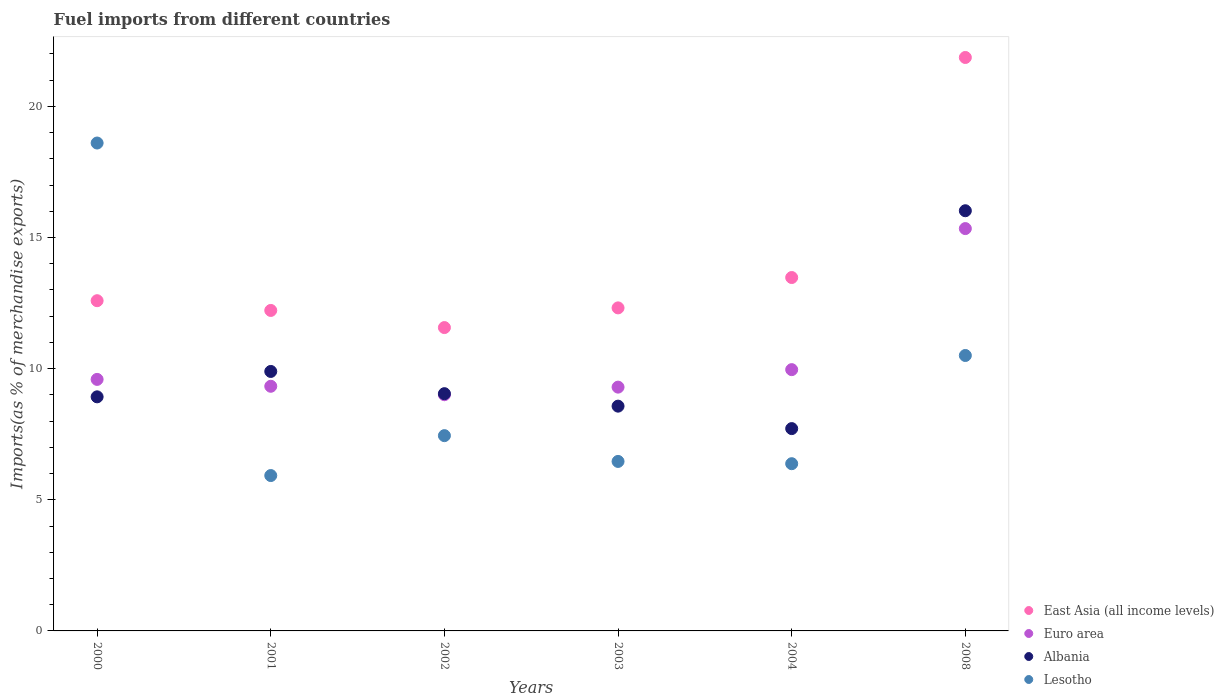Is the number of dotlines equal to the number of legend labels?
Give a very brief answer. Yes. What is the percentage of imports to different countries in Lesotho in 2000?
Provide a succinct answer. 18.6. Across all years, what is the maximum percentage of imports to different countries in Albania?
Ensure brevity in your answer.  16.02. Across all years, what is the minimum percentage of imports to different countries in Lesotho?
Make the answer very short. 5.92. In which year was the percentage of imports to different countries in Lesotho maximum?
Offer a very short reply. 2000. What is the total percentage of imports to different countries in East Asia (all income levels) in the graph?
Offer a very short reply. 84.03. What is the difference between the percentage of imports to different countries in Lesotho in 2001 and that in 2003?
Make the answer very short. -0.54. What is the difference between the percentage of imports to different countries in Euro area in 2003 and the percentage of imports to different countries in Lesotho in 2000?
Keep it short and to the point. -9.31. What is the average percentage of imports to different countries in Albania per year?
Your answer should be compact. 10.03. In the year 2003, what is the difference between the percentage of imports to different countries in Euro area and percentage of imports to different countries in Lesotho?
Your response must be concise. 2.83. In how many years, is the percentage of imports to different countries in Lesotho greater than 11 %?
Keep it short and to the point. 1. What is the ratio of the percentage of imports to different countries in Euro area in 2001 to that in 2004?
Your answer should be compact. 0.94. Is the percentage of imports to different countries in Lesotho in 2000 less than that in 2003?
Your answer should be compact. No. What is the difference between the highest and the second highest percentage of imports to different countries in Albania?
Your answer should be compact. 6.13. What is the difference between the highest and the lowest percentage of imports to different countries in Albania?
Provide a short and direct response. 8.31. Is the sum of the percentage of imports to different countries in Lesotho in 2000 and 2003 greater than the maximum percentage of imports to different countries in East Asia (all income levels) across all years?
Offer a very short reply. Yes. Is it the case that in every year, the sum of the percentage of imports to different countries in Euro area and percentage of imports to different countries in Lesotho  is greater than the percentage of imports to different countries in Albania?
Your answer should be very brief. Yes. Is the percentage of imports to different countries in Albania strictly less than the percentage of imports to different countries in Lesotho over the years?
Give a very brief answer. No. How many years are there in the graph?
Your response must be concise. 6. What is the difference between two consecutive major ticks on the Y-axis?
Your answer should be compact. 5. Where does the legend appear in the graph?
Make the answer very short. Bottom right. How are the legend labels stacked?
Your answer should be compact. Vertical. What is the title of the graph?
Your answer should be compact. Fuel imports from different countries. What is the label or title of the X-axis?
Give a very brief answer. Years. What is the label or title of the Y-axis?
Your answer should be compact. Imports(as % of merchandise exports). What is the Imports(as % of merchandise exports) in East Asia (all income levels) in 2000?
Your answer should be compact. 12.59. What is the Imports(as % of merchandise exports) of Euro area in 2000?
Make the answer very short. 9.59. What is the Imports(as % of merchandise exports) of Albania in 2000?
Keep it short and to the point. 8.93. What is the Imports(as % of merchandise exports) in Lesotho in 2000?
Ensure brevity in your answer.  18.6. What is the Imports(as % of merchandise exports) in East Asia (all income levels) in 2001?
Make the answer very short. 12.22. What is the Imports(as % of merchandise exports) of Euro area in 2001?
Give a very brief answer. 9.33. What is the Imports(as % of merchandise exports) of Albania in 2001?
Your response must be concise. 9.89. What is the Imports(as % of merchandise exports) of Lesotho in 2001?
Offer a very short reply. 5.92. What is the Imports(as % of merchandise exports) in East Asia (all income levels) in 2002?
Keep it short and to the point. 11.57. What is the Imports(as % of merchandise exports) of Euro area in 2002?
Offer a very short reply. 9.01. What is the Imports(as % of merchandise exports) in Albania in 2002?
Ensure brevity in your answer.  9.05. What is the Imports(as % of merchandise exports) of Lesotho in 2002?
Your answer should be very brief. 7.45. What is the Imports(as % of merchandise exports) of East Asia (all income levels) in 2003?
Your answer should be very brief. 12.32. What is the Imports(as % of merchandise exports) of Euro area in 2003?
Give a very brief answer. 9.3. What is the Imports(as % of merchandise exports) of Albania in 2003?
Give a very brief answer. 8.57. What is the Imports(as % of merchandise exports) in Lesotho in 2003?
Provide a short and direct response. 6.46. What is the Imports(as % of merchandise exports) in East Asia (all income levels) in 2004?
Provide a succinct answer. 13.47. What is the Imports(as % of merchandise exports) in Euro area in 2004?
Keep it short and to the point. 9.96. What is the Imports(as % of merchandise exports) of Albania in 2004?
Your response must be concise. 7.71. What is the Imports(as % of merchandise exports) of Lesotho in 2004?
Make the answer very short. 6.38. What is the Imports(as % of merchandise exports) in East Asia (all income levels) in 2008?
Offer a terse response. 21.87. What is the Imports(as % of merchandise exports) of Euro area in 2008?
Your response must be concise. 15.34. What is the Imports(as % of merchandise exports) in Albania in 2008?
Offer a terse response. 16.02. What is the Imports(as % of merchandise exports) of Lesotho in 2008?
Your response must be concise. 10.5. Across all years, what is the maximum Imports(as % of merchandise exports) in East Asia (all income levels)?
Offer a terse response. 21.87. Across all years, what is the maximum Imports(as % of merchandise exports) in Euro area?
Your answer should be very brief. 15.34. Across all years, what is the maximum Imports(as % of merchandise exports) in Albania?
Provide a succinct answer. 16.02. Across all years, what is the maximum Imports(as % of merchandise exports) in Lesotho?
Provide a short and direct response. 18.6. Across all years, what is the minimum Imports(as % of merchandise exports) in East Asia (all income levels)?
Provide a succinct answer. 11.57. Across all years, what is the minimum Imports(as % of merchandise exports) of Euro area?
Offer a terse response. 9.01. Across all years, what is the minimum Imports(as % of merchandise exports) of Albania?
Your answer should be compact. 7.71. Across all years, what is the minimum Imports(as % of merchandise exports) of Lesotho?
Ensure brevity in your answer.  5.92. What is the total Imports(as % of merchandise exports) in East Asia (all income levels) in the graph?
Your response must be concise. 84.03. What is the total Imports(as % of merchandise exports) of Euro area in the graph?
Your answer should be very brief. 62.52. What is the total Imports(as % of merchandise exports) in Albania in the graph?
Provide a succinct answer. 60.17. What is the total Imports(as % of merchandise exports) of Lesotho in the graph?
Provide a succinct answer. 55.31. What is the difference between the Imports(as % of merchandise exports) of East Asia (all income levels) in 2000 and that in 2001?
Offer a terse response. 0.37. What is the difference between the Imports(as % of merchandise exports) in Euro area in 2000 and that in 2001?
Provide a succinct answer. 0.26. What is the difference between the Imports(as % of merchandise exports) in Albania in 2000 and that in 2001?
Your answer should be very brief. -0.97. What is the difference between the Imports(as % of merchandise exports) of Lesotho in 2000 and that in 2001?
Your answer should be compact. 12.68. What is the difference between the Imports(as % of merchandise exports) of East Asia (all income levels) in 2000 and that in 2002?
Offer a very short reply. 1.02. What is the difference between the Imports(as % of merchandise exports) in Euro area in 2000 and that in 2002?
Provide a short and direct response. 0.58. What is the difference between the Imports(as % of merchandise exports) of Albania in 2000 and that in 2002?
Keep it short and to the point. -0.12. What is the difference between the Imports(as % of merchandise exports) of Lesotho in 2000 and that in 2002?
Your answer should be compact. 11.16. What is the difference between the Imports(as % of merchandise exports) of East Asia (all income levels) in 2000 and that in 2003?
Your answer should be compact. 0.27. What is the difference between the Imports(as % of merchandise exports) in Euro area in 2000 and that in 2003?
Offer a terse response. 0.29. What is the difference between the Imports(as % of merchandise exports) in Albania in 2000 and that in 2003?
Provide a short and direct response. 0.36. What is the difference between the Imports(as % of merchandise exports) of Lesotho in 2000 and that in 2003?
Ensure brevity in your answer.  12.14. What is the difference between the Imports(as % of merchandise exports) in East Asia (all income levels) in 2000 and that in 2004?
Provide a short and direct response. -0.88. What is the difference between the Imports(as % of merchandise exports) in Euro area in 2000 and that in 2004?
Give a very brief answer. -0.37. What is the difference between the Imports(as % of merchandise exports) in Albania in 2000 and that in 2004?
Your answer should be very brief. 1.21. What is the difference between the Imports(as % of merchandise exports) in Lesotho in 2000 and that in 2004?
Make the answer very short. 12.23. What is the difference between the Imports(as % of merchandise exports) of East Asia (all income levels) in 2000 and that in 2008?
Offer a terse response. -9.27. What is the difference between the Imports(as % of merchandise exports) of Euro area in 2000 and that in 2008?
Offer a very short reply. -5.75. What is the difference between the Imports(as % of merchandise exports) in Albania in 2000 and that in 2008?
Your answer should be very brief. -7.1. What is the difference between the Imports(as % of merchandise exports) of Lesotho in 2000 and that in 2008?
Give a very brief answer. 8.1. What is the difference between the Imports(as % of merchandise exports) in East Asia (all income levels) in 2001 and that in 2002?
Provide a short and direct response. 0.65. What is the difference between the Imports(as % of merchandise exports) in Euro area in 2001 and that in 2002?
Provide a succinct answer. 0.32. What is the difference between the Imports(as % of merchandise exports) in Albania in 2001 and that in 2002?
Ensure brevity in your answer.  0.85. What is the difference between the Imports(as % of merchandise exports) in Lesotho in 2001 and that in 2002?
Your answer should be very brief. -1.52. What is the difference between the Imports(as % of merchandise exports) in East Asia (all income levels) in 2001 and that in 2003?
Offer a very short reply. -0.1. What is the difference between the Imports(as % of merchandise exports) of Euro area in 2001 and that in 2003?
Your response must be concise. 0.03. What is the difference between the Imports(as % of merchandise exports) in Albania in 2001 and that in 2003?
Your response must be concise. 1.32. What is the difference between the Imports(as % of merchandise exports) of Lesotho in 2001 and that in 2003?
Provide a succinct answer. -0.54. What is the difference between the Imports(as % of merchandise exports) of East Asia (all income levels) in 2001 and that in 2004?
Offer a terse response. -1.25. What is the difference between the Imports(as % of merchandise exports) in Euro area in 2001 and that in 2004?
Your answer should be very brief. -0.63. What is the difference between the Imports(as % of merchandise exports) of Albania in 2001 and that in 2004?
Provide a short and direct response. 2.18. What is the difference between the Imports(as % of merchandise exports) of Lesotho in 2001 and that in 2004?
Your answer should be very brief. -0.45. What is the difference between the Imports(as % of merchandise exports) of East Asia (all income levels) in 2001 and that in 2008?
Provide a succinct answer. -9.65. What is the difference between the Imports(as % of merchandise exports) in Euro area in 2001 and that in 2008?
Offer a very short reply. -6.01. What is the difference between the Imports(as % of merchandise exports) in Albania in 2001 and that in 2008?
Your answer should be compact. -6.13. What is the difference between the Imports(as % of merchandise exports) of Lesotho in 2001 and that in 2008?
Offer a terse response. -4.58. What is the difference between the Imports(as % of merchandise exports) in East Asia (all income levels) in 2002 and that in 2003?
Give a very brief answer. -0.75. What is the difference between the Imports(as % of merchandise exports) of Euro area in 2002 and that in 2003?
Provide a succinct answer. -0.29. What is the difference between the Imports(as % of merchandise exports) of Albania in 2002 and that in 2003?
Offer a very short reply. 0.48. What is the difference between the Imports(as % of merchandise exports) in Lesotho in 2002 and that in 2003?
Give a very brief answer. 0.98. What is the difference between the Imports(as % of merchandise exports) of East Asia (all income levels) in 2002 and that in 2004?
Ensure brevity in your answer.  -1.91. What is the difference between the Imports(as % of merchandise exports) of Euro area in 2002 and that in 2004?
Ensure brevity in your answer.  -0.96. What is the difference between the Imports(as % of merchandise exports) of Albania in 2002 and that in 2004?
Ensure brevity in your answer.  1.33. What is the difference between the Imports(as % of merchandise exports) of Lesotho in 2002 and that in 2004?
Keep it short and to the point. 1.07. What is the difference between the Imports(as % of merchandise exports) in East Asia (all income levels) in 2002 and that in 2008?
Keep it short and to the point. -10.3. What is the difference between the Imports(as % of merchandise exports) in Euro area in 2002 and that in 2008?
Provide a succinct answer. -6.33. What is the difference between the Imports(as % of merchandise exports) of Albania in 2002 and that in 2008?
Your answer should be very brief. -6.97. What is the difference between the Imports(as % of merchandise exports) in Lesotho in 2002 and that in 2008?
Give a very brief answer. -3.06. What is the difference between the Imports(as % of merchandise exports) in East Asia (all income levels) in 2003 and that in 2004?
Keep it short and to the point. -1.16. What is the difference between the Imports(as % of merchandise exports) in Euro area in 2003 and that in 2004?
Your response must be concise. -0.67. What is the difference between the Imports(as % of merchandise exports) of Albania in 2003 and that in 2004?
Offer a very short reply. 0.86. What is the difference between the Imports(as % of merchandise exports) of Lesotho in 2003 and that in 2004?
Ensure brevity in your answer.  0.09. What is the difference between the Imports(as % of merchandise exports) in East Asia (all income levels) in 2003 and that in 2008?
Provide a short and direct response. -9.55. What is the difference between the Imports(as % of merchandise exports) of Euro area in 2003 and that in 2008?
Provide a short and direct response. -6.05. What is the difference between the Imports(as % of merchandise exports) in Albania in 2003 and that in 2008?
Make the answer very short. -7.45. What is the difference between the Imports(as % of merchandise exports) in Lesotho in 2003 and that in 2008?
Offer a very short reply. -4.04. What is the difference between the Imports(as % of merchandise exports) in East Asia (all income levels) in 2004 and that in 2008?
Keep it short and to the point. -8.39. What is the difference between the Imports(as % of merchandise exports) of Euro area in 2004 and that in 2008?
Your response must be concise. -5.38. What is the difference between the Imports(as % of merchandise exports) of Albania in 2004 and that in 2008?
Provide a short and direct response. -8.31. What is the difference between the Imports(as % of merchandise exports) of Lesotho in 2004 and that in 2008?
Offer a very short reply. -4.13. What is the difference between the Imports(as % of merchandise exports) in East Asia (all income levels) in 2000 and the Imports(as % of merchandise exports) in Euro area in 2001?
Your response must be concise. 3.26. What is the difference between the Imports(as % of merchandise exports) in East Asia (all income levels) in 2000 and the Imports(as % of merchandise exports) in Albania in 2001?
Your answer should be compact. 2.7. What is the difference between the Imports(as % of merchandise exports) of East Asia (all income levels) in 2000 and the Imports(as % of merchandise exports) of Lesotho in 2001?
Offer a very short reply. 6.67. What is the difference between the Imports(as % of merchandise exports) of Euro area in 2000 and the Imports(as % of merchandise exports) of Albania in 2001?
Your answer should be very brief. -0.3. What is the difference between the Imports(as % of merchandise exports) in Euro area in 2000 and the Imports(as % of merchandise exports) in Lesotho in 2001?
Offer a very short reply. 3.67. What is the difference between the Imports(as % of merchandise exports) of Albania in 2000 and the Imports(as % of merchandise exports) of Lesotho in 2001?
Your answer should be very brief. 3. What is the difference between the Imports(as % of merchandise exports) of East Asia (all income levels) in 2000 and the Imports(as % of merchandise exports) of Euro area in 2002?
Offer a terse response. 3.59. What is the difference between the Imports(as % of merchandise exports) in East Asia (all income levels) in 2000 and the Imports(as % of merchandise exports) in Albania in 2002?
Your answer should be very brief. 3.54. What is the difference between the Imports(as % of merchandise exports) of East Asia (all income levels) in 2000 and the Imports(as % of merchandise exports) of Lesotho in 2002?
Offer a very short reply. 5.15. What is the difference between the Imports(as % of merchandise exports) of Euro area in 2000 and the Imports(as % of merchandise exports) of Albania in 2002?
Offer a very short reply. 0.54. What is the difference between the Imports(as % of merchandise exports) of Euro area in 2000 and the Imports(as % of merchandise exports) of Lesotho in 2002?
Offer a very short reply. 2.14. What is the difference between the Imports(as % of merchandise exports) in Albania in 2000 and the Imports(as % of merchandise exports) in Lesotho in 2002?
Give a very brief answer. 1.48. What is the difference between the Imports(as % of merchandise exports) in East Asia (all income levels) in 2000 and the Imports(as % of merchandise exports) in Euro area in 2003?
Your answer should be very brief. 3.3. What is the difference between the Imports(as % of merchandise exports) of East Asia (all income levels) in 2000 and the Imports(as % of merchandise exports) of Albania in 2003?
Offer a terse response. 4.02. What is the difference between the Imports(as % of merchandise exports) of East Asia (all income levels) in 2000 and the Imports(as % of merchandise exports) of Lesotho in 2003?
Keep it short and to the point. 6.13. What is the difference between the Imports(as % of merchandise exports) in Euro area in 2000 and the Imports(as % of merchandise exports) in Albania in 2003?
Provide a succinct answer. 1.02. What is the difference between the Imports(as % of merchandise exports) of Euro area in 2000 and the Imports(as % of merchandise exports) of Lesotho in 2003?
Offer a very short reply. 3.13. What is the difference between the Imports(as % of merchandise exports) in Albania in 2000 and the Imports(as % of merchandise exports) in Lesotho in 2003?
Your answer should be very brief. 2.46. What is the difference between the Imports(as % of merchandise exports) in East Asia (all income levels) in 2000 and the Imports(as % of merchandise exports) in Euro area in 2004?
Offer a very short reply. 2.63. What is the difference between the Imports(as % of merchandise exports) in East Asia (all income levels) in 2000 and the Imports(as % of merchandise exports) in Albania in 2004?
Your answer should be very brief. 4.88. What is the difference between the Imports(as % of merchandise exports) in East Asia (all income levels) in 2000 and the Imports(as % of merchandise exports) in Lesotho in 2004?
Offer a very short reply. 6.21. What is the difference between the Imports(as % of merchandise exports) of Euro area in 2000 and the Imports(as % of merchandise exports) of Albania in 2004?
Offer a terse response. 1.88. What is the difference between the Imports(as % of merchandise exports) of Euro area in 2000 and the Imports(as % of merchandise exports) of Lesotho in 2004?
Offer a terse response. 3.21. What is the difference between the Imports(as % of merchandise exports) of Albania in 2000 and the Imports(as % of merchandise exports) of Lesotho in 2004?
Ensure brevity in your answer.  2.55. What is the difference between the Imports(as % of merchandise exports) of East Asia (all income levels) in 2000 and the Imports(as % of merchandise exports) of Euro area in 2008?
Offer a terse response. -2.75. What is the difference between the Imports(as % of merchandise exports) of East Asia (all income levels) in 2000 and the Imports(as % of merchandise exports) of Albania in 2008?
Give a very brief answer. -3.43. What is the difference between the Imports(as % of merchandise exports) in East Asia (all income levels) in 2000 and the Imports(as % of merchandise exports) in Lesotho in 2008?
Ensure brevity in your answer.  2.09. What is the difference between the Imports(as % of merchandise exports) in Euro area in 2000 and the Imports(as % of merchandise exports) in Albania in 2008?
Ensure brevity in your answer.  -6.43. What is the difference between the Imports(as % of merchandise exports) in Euro area in 2000 and the Imports(as % of merchandise exports) in Lesotho in 2008?
Give a very brief answer. -0.91. What is the difference between the Imports(as % of merchandise exports) in Albania in 2000 and the Imports(as % of merchandise exports) in Lesotho in 2008?
Offer a very short reply. -1.58. What is the difference between the Imports(as % of merchandise exports) of East Asia (all income levels) in 2001 and the Imports(as % of merchandise exports) of Euro area in 2002?
Provide a short and direct response. 3.21. What is the difference between the Imports(as % of merchandise exports) in East Asia (all income levels) in 2001 and the Imports(as % of merchandise exports) in Albania in 2002?
Provide a short and direct response. 3.17. What is the difference between the Imports(as % of merchandise exports) in East Asia (all income levels) in 2001 and the Imports(as % of merchandise exports) in Lesotho in 2002?
Give a very brief answer. 4.77. What is the difference between the Imports(as % of merchandise exports) of Euro area in 2001 and the Imports(as % of merchandise exports) of Albania in 2002?
Your answer should be compact. 0.28. What is the difference between the Imports(as % of merchandise exports) of Euro area in 2001 and the Imports(as % of merchandise exports) of Lesotho in 2002?
Your answer should be compact. 1.88. What is the difference between the Imports(as % of merchandise exports) of Albania in 2001 and the Imports(as % of merchandise exports) of Lesotho in 2002?
Make the answer very short. 2.45. What is the difference between the Imports(as % of merchandise exports) in East Asia (all income levels) in 2001 and the Imports(as % of merchandise exports) in Euro area in 2003?
Your response must be concise. 2.92. What is the difference between the Imports(as % of merchandise exports) of East Asia (all income levels) in 2001 and the Imports(as % of merchandise exports) of Albania in 2003?
Your answer should be compact. 3.65. What is the difference between the Imports(as % of merchandise exports) in East Asia (all income levels) in 2001 and the Imports(as % of merchandise exports) in Lesotho in 2003?
Make the answer very short. 5.76. What is the difference between the Imports(as % of merchandise exports) in Euro area in 2001 and the Imports(as % of merchandise exports) in Albania in 2003?
Make the answer very short. 0.76. What is the difference between the Imports(as % of merchandise exports) in Euro area in 2001 and the Imports(as % of merchandise exports) in Lesotho in 2003?
Provide a short and direct response. 2.87. What is the difference between the Imports(as % of merchandise exports) in Albania in 2001 and the Imports(as % of merchandise exports) in Lesotho in 2003?
Offer a very short reply. 3.43. What is the difference between the Imports(as % of merchandise exports) in East Asia (all income levels) in 2001 and the Imports(as % of merchandise exports) in Euro area in 2004?
Provide a succinct answer. 2.26. What is the difference between the Imports(as % of merchandise exports) in East Asia (all income levels) in 2001 and the Imports(as % of merchandise exports) in Albania in 2004?
Ensure brevity in your answer.  4.51. What is the difference between the Imports(as % of merchandise exports) of East Asia (all income levels) in 2001 and the Imports(as % of merchandise exports) of Lesotho in 2004?
Your response must be concise. 5.84. What is the difference between the Imports(as % of merchandise exports) of Euro area in 2001 and the Imports(as % of merchandise exports) of Albania in 2004?
Your answer should be compact. 1.61. What is the difference between the Imports(as % of merchandise exports) in Euro area in 2001 and the Imports(as % of merchandise exports) in Lesotho in 2004?
Provide a succinct answer. 2.95. What is the difference between the Imports(as % of merchandise exports) in Albania in 2001 and the Imports(as % of merchandise exports) in Lesotho in 2004?
Ensure brevity in your answer.  3.52. What is the difference between the Imports(as % of merchandise exports) of East Asia (all income levels) in 2001 and the Imports(as % of merchandise exports) of Euro area in 2008?
Make the answer very short. -3.12. What is the difference between the Imports(as % of merchandise exports) of East Asia (all income levels) in 2001 and the Imports(as % of merchandise exports) of Albania in 2008?
Offer a very short reply. -3.8. What is the difference between the Imports(as % of merchandise exports) of East Asia (all income levels) in 2001 and the Imports(as % of merchandise exports) of Lesotho in 2008?
Your response must be concise. 1.72. What is the difference between the Imports(as % of merchandise exports) of Euro area in 2001 and the Imports(as % of merchandise exports) of Albania in 2008?
Offer a terse response. -6.69. What is the difference between the Imports(as % of merchandise exports) of Euro area in 2001 and the Imports(as % of merchandise exports) of Lesotho in 2008?
Offer a very short reply. -1.17. What is the difference between the Imports(as % of merchandise exports) in Albania in 2001 and the Imports(as % of merchandise exports) in Lesotho in 2008?
Keep it short and to the point. -0.61. What is the difference between the Imports(as % of merchandise exports) of East Asia (all income levels) in 2002 and the Imports(as % of merchandise exports) of Euro area in 2003?
Provide a succinct answer. 2.27. What is the difference between the Imports(as % of merchandise exports) of East Asia (all income levels) in 2002 and the Imports(as % of merchandise exports) of Albania in 2003?
Ensure brevity in your answer.  3. What is the difference between the Imports(as % of merchandise exports) in East Asia (all income levels) in 2002 and the Imports(as % of merchandise exports) in Lesotho in 2003?
Offer a very short reply. 5.1. What is the difference between the Imports(as % of merchandise exports) in Euro area in 2002 and the Imports(as % of merchandise exports) in Albania in 2003?
Your answer should be very brief. 0.44. What is the difference between the Imports(as % of merchandise exports) in Euro area in 2002 and the Imports(as % of merchandise exports) in Lesotho in 2003?
Your response must be concise. 2.54. What is the difference between the Imports(as % of merchandise exports) in Albania in 2002 and the Imports(as % of merchandise exports) in Lesotho in 2003?
Ensure brevity in your answer.  2.58. What is the difference between the Imports(as % of merchandise exports) of East Asia (all income levels) in 2002 and the Imports(as % of merchandise exports) of Euro area in 2004?
Provide a succinct answer. 1.6. What is the difference between the Imports(as % of merchandise exports) in East Asia (all income levels) in 2002 and the Imports(as % of merchandise exports) in Albania in 2004?
Offer a very short reply. 3.85. What is the difference between the Imports(as % of merchandise exports) in East Asia (all income levels) in 2002 and the Imports(as % of merchandise exports) in Lesotho in 2004?
Ensure brevity in your answer.  5.19. What is the difference between the Imports(as % of merchandise exports) of Euro area in 2002 and the Imports(as % of merchandise exports) of Albania in 2004?
Your answer should be very brief. 1.29. What is the difference between the Imports(as % of merchandise exports) of Euro area in 2002 and the Imports(as % of merchandise exports) of Lesotho in 2004?
Your answer should be very brief. 2.63. What is the difference between the Imports(as % of merchandise exports) of Albania in 2002 and the Imports(as % of merchandise exports) of Lesotho in 2004?
Your answer should be compact. 2.67. What is the difference between the Imports(as % of merchandise exports) in East Asia (all income levels) in 2002 and the Imports(as % of merchandise exports) in Euro area in 2008?
Your answer should be compact. -3.77. What is the difference between the Imports(as % of merchandise exports) of East Asia (all income levels) in 2002 and the Imports(as % of merchandise exports) of Albania in 2008?
Keep it short and to the point. -4.45. What is the difference between the Imports(as % of merchandise exports) of East Asia (all income levels) in 2002 and the Imports(as % of merchandise exports) of Lesotho in 2008?
Offer a terse response. 1.06. What is the difference between the Imports(as % of merchandise exports) in Euro area in 2002 and the Imports(as % of merchandise exports) in Albania in 2008?
Offer a terse response. -7.02. What is the difference between the Imports(as % of merchandise exports) in Euro area in 2002 and the Imports(as % of merchandise exports) in Lesotho in 2008?
Give a very brief answer. -1.5. What is the difference between the Imports(as % of merchandise exports) in Albania in 2002 and the Imports(as % of merchandise exports) in Lesotho in 2008?
Offer a very short reply. -1.46. What is the difference between the Imports(as % of merchandise exports) of East Asia (all income levels) in 2003 and the Imports(as % of merchandise exports) of Euro area in 2004?
Your answer should be compact. 2.35. What is the difference between the Imports(as % of merchandise exports) of East Asia (all income levels) in 2003 and the Imports(as % of merchandise exports) of Albania in 2004?
Provide a succinct answer. 4.6. What is the difference between the Imports(as % of merchandise exports) in East Asia (all income levels) in 2003 and the Imports(as % of merchandise exports) in Lesotho in 2004?
Provide a succinct answer. 5.94. What is the difference between the Imports(as % of merchandise exports) of Euro area in 2003 and the Imports(as % of merchandise exports) of Albania in 2004?
Ensure brevity in your answer.  1.58. What is the difference between the Imports(as % of merchandise exports) in Euro area in 2003 and the Imports(as % of merchandise exports) in Lesotho in 2004?
Provide a succinct answer. 2.92. What is the difference between the Imports(as % of merchandise exports) of Albania in 2003 and the Imports(as % of merchandise exports) of Lesotho in 2004?
Keep it short and to the point. 2.19. What is the difference between the Imports(as % of merchandise exports) of East Asia (all income levels) in 2003 and the Imports(as % of merchandise exports) of Euro area in 2008?
Ensure brevity in your answer.  -3.02. What is the difference between the Imports(as % of merchandise exports) in East Asia (all income levels) in 2003 and the Imports(as % of merchandise exports) in Albania in 2008?
Keep it short and to the point. -3.7. What is the difference between the Imports(as % of merchandise exports) of East Asia (all income levels) in 2003 and the Imports(as % of merchandise exports) of Lesotho in 2008?
Offer a terse response. 1.81. What is the difference between the Imports(as % of merchandise exports) in Euro area in 2003 and the Imports(as % of merchandise exports) in Albania in 2008?
Give a very brief answer. -6.73. What is the difference between the Imports(as % of merchandise exports) of Euro area in 2003 and the Imports(as % of merchandise exports) of Lesotho in 2008?
Offer a very short reply. -1.21. What is the difference between the Imports(as % of merchandise exports) in Albania in 2003 and the Imports(as % of merchandise exports) in Lesotho in 2008?
Your response must be concise. -1.93. What is the difference between the Imports(as % of merchandise exports) of East Asia (all income levels) in 2004 and the Imports(as % of merchandise exports) of Euro area in 2008?
Ensure brevity in your answer.  -1.87. What is the difference between the Imports(as % of merchandise exports) in East Asia (all income levels) in 2004 and the Imports(as % of merchandise exports) in Albania in 2008?
Provide a short and direct response. -2.55. What is the difference between the Imports(as % of merchandise exports) of East Asia (all income levels) in 2004 and the Imports(as % of merchandise exports) of Lesotho in 2008?
Your answer should be compact. 2.97. What is the difference between the Imports(as % of merchandise exports) of Euro area in 2004 and the Imports(as % of merchandise exports) of Albania in 2008?
Your response must be concise. -6.06. What is the difference between the Imports(as % of merchandise exports) of Euro area in 2004 and the Imports(as % of merchandise exports) of Lesotho in 2008?
Ensure brevity in your answer.  -0.54. What is the difference between the Imports(as % of merchandise exports) in Albania in 2004 and the Imports(as % of merchandise exports) in Lesotho in 2008?
Your response must be concise. -2.79. What is the average Imports(as % of merchandise exports) of East Asia (all income levels) per year?
Your answer should be very brief. 14.01. What is the average Imports(as % of merchandise exports) in Euro area per year?
Offer a very short reply. 10.42. What is the average Imports(as % of merchandise exports) in Albania per year?
Your answer should be compact. 10.03. What is the average Imports(as % of merchandise exports) in Lesotho per year?
Give a very brief answer. 9.22. In the year 2000, what is the difference between the Imports(as % of merchandise exports) in East Asia (all income levels) and Imports(as % of merchandise exports) in Euro area?
Your answer should be compact. 3. In the year 2000, what is the difference between the Imports(as % of merchandise exports) of East Asia (all income levels) and Imports(as % of merchandise exports) of Albania?
Ensure brevity in your answer.  3.67. In the year 2000, what is the difference between the Imports(as % of merchandise exports) of East Asia (all income levels) and Imports(as % of merchandise exports) of Lesotho?
Offer a very short reply. -6.01. In the year 2000, what is the difference between the Imports(as % of merchandise exports) of Euro area and Imports(as % of merchandise exports) of Albania?
Provide a short and direct response. 0.66. In the year 2000, what is the difference between the Imports(as % of merchandise exports) of Euro area and Imports(as % of merchandise exports) of Lesotho?
Make the answer very short. -9.01. In the year 2000, what is the difference between the Imports(as % of merchandise exports) in Albania and Imports(as % of merchandise exports) in Lesotho?
Offer a very short reply. -9.68. In the year 2001, what is the difference between the Imports(as % of merchandise exports) of East Asia (all income levels) and Imports(as % of merchandise exports) of Euro area?
Keep it short and to the point. 2.89. In the year 2001, what is the difference between the Imports(as % of merchandise exports) in East Asia (all income levels) and Imports(as % of merchandise exports) in Albania?
Provide a short and direct response. 2.33. In the year 2001, what is the difference between the Imports(as % of merchandise exports) of East Asia (all income levels) and Imports(as % of merchandise exports) of Lesotho?
Your answer should be compact. 6.3. In the year 2001, what is the difference between the Imports(as % of merchandise exports) in Euro area and Imports(as % of merchandise exports) in Albania?
Make the answer very short. -0.57. In the year 2001, what is the difference between the Imports(as % of merchandise exports) in Euro area and Imports(as % of merchandise exports) in Lesotho?
Your answer should be very brief. 3.4. In the year 2001, what is the difference between the Imports(as % of merchandise exports) of Albania and Imports(as % of merchandise exports) of Lesotho?
Your response must be concise. 3.97. In the year 2002, what is the difference between the Imports(as % of merchandise exports) in East Asia (all income levels) and Imports(as % of merchandise exports) in Euro area?
Keep it short and to the point. 2.56. In the year 2002, what is the difference between the Imports(as % of merchandise exports) in East Asia (all income levels) and Imports(as % of merchandise exports) in Albania?
Provide a short and direct response. 2.52. In the year 2002, what is the difference between the Imports(as % of merchandise exports) in East Asia (all income levels) and Imports(as % of merchandise exports) in Lesotho?
Make the answer very short. 4.12. In the year 2002, what is the difference between the Imports(as % of merchandise exports) in Euro area and Imports(as % of merchandise exports) in Albania?
Provide a succinct answer. -0.04. In the year 2002, what is the difference between the Imports(as % of merchandise exports) in Euro area and Imports(as % of merchandise exports) in Lesotho?
Your response must be concise. 1.56. In the year 2002, what is the difference between the Imports(as % of merchandise exports) of Albania and Imports(as % of merchandise exports) of Lesotho?
Provide a succinct answer. 1.6. In the year 2003, what is the difference between the Imports(as % of merchandise exports) in East Asia (all income levels) and Imports(as % of merchandise exports) in Euro area?
Keep it short and to the point. 3.02. In the year 2003, what is the difference between the Imports(as % of merchandise exports) of East Asia (all income levels) and Imports(as % of merchandise exports) of Albania?
Provide a short and direct response. 3.75. In the year 2003, what is the difference between the Imports(as % of merchandise exports) of East Asia (all income levels) and Imports(as % of merchandise exports) of Lesotho?
Your response must be concise. 5.85. In the year 2003, what is the difference between the Imports(as % of merchandise exports) in Euro area and Imports(as % of merchandise exports) in Albania?
Ensure brevity in your answer.  0.73. In the year 2003, what is the difference between the Imports(as % of merchandise exports) in Euro area and Imports(as % of merchandise exports) in Lesotho?
Make the answer very short. 2.83. In the year 2003, what is the difference between the Imports(as % of merchandise exports) in Albania and Imports(as % of merchandise exports) in Lesotho?
Give a very brief answer. 2.11. In the year 2004, what is the difference between the Imports(as % of merchandise exports) of East Asia (all income levels) and Imports(as % of merchandise exports) of Euro area?
Provide a short and direct response. 3.51. In the year 2004, what is the difference between the Imports(as % of merchandise exports) of East Asia (all income levels) and Imports(as % of merchandise exports) of Albania?
Offer a terse response. 5.76. In the year 2004, what is the difference between the Imports(as % of merchandise exports) in East Asia (all income levels) and Imports(as % of merchandise exports) in Lesotho?
Your answer should be compact. 7.1. In the year 2004, what is the difference between the Imports(as % of merchandise exports) in Euro area and Imports(as % of merchandise exports) in Albania?
Make the answer very short. 2.25. In the year 2004, what is the difference between the Imports(as % of merchandise exports) in Euro area and Imports(as % of merchandise exports) in Lesotho?
Keep it short and to the point. 3.59. In the year 2004, what is the difference between the Imports(as % of merchandise exports) of Albania and Imports(as % of merchandise exports) of Lesotho?
Your answer should be very brief. 1.34. In the year 2008, what is the difference between the Imports(as % of merchandise exports) in East Asia (all income levels) and Imports(as % of merchandise exports) in Euro area?
Provide a succinct answer. 6.52. In the year 2008, what is the difference between the Imports(as % of merchandise exports) in East Asia (all income levels) and Imports(as % of merchandise exports) in Albania?
Provide a short and direct response. 5.84. In the year 2008, what is the difference between the Imports(as % of merchandise exports) of East Asia (all income levels) and Imports(as % of merchandise exports) of Lesotho?
Your answer should be very brief. 11.36. In the year 2008, what is the difference between the Imports(as % of merchandise exports) in Euro area and Imports(as % of merchandise exports) in Albania?
Provide a short and direct response. -0.68. In the year 2008, what is the difference between the Imports(as % of merchandise exports) of Euro area and Imports(as % of merchandise exports) of Lesotho?
Your response must be concise. 4.84. In the year 2008, what is the difference between the Imports(as % of merchandise exports) in Albania and Imports(as % of merchandise exports) in Lesotho?
Offer a very short reply. 5.52. What is the ratio of the Imports(as % of merchandise exports) of East Asia (all income levels) in 2000 to that in 2001?
Offer a very short reply. 1.03. What is the ratio of the Imports(as % of merchandise exports) of Euro area in 2000 to that in 2001?
Provide a succinct answer. 1.03. What is the ratio of the Imports(as % of merchandise exports) of Albania in 2000 to that in 2001?
Provide a succinct answer. 0.9. What is the ratio of the Imports(as % of merchandise exports) in Lesotho in 2000 to that in 2001?
Keep it short and to the point. 3.14. What is the ratio of the Imports(as % of merchandise exports) in East Asia (all income levels) in 2000 to that in 2002?
Keep it short and to the point. 1.09. What is the ratio of the Imports(as % of merchandise exports) in Euro area in 2000 to that in 2002?
Your answer should be very brief. 1.06. What is the ratio of the Imports(as % of merchandise exports) of Albania in 2000 to that in 2002?
Make the answer very short. 0.99. What is the ratio of the Imports(as % of merchandise exports) of Lesotho in 2000 to that in 2002?
Offer a terse response. 2.5. What is the ratio of the Imports(as % of merchandise exports) of East Asia (all income levels) in 2000 to that in 2003?
Give a very brief answer. 1.02. What is the ratio of the Imports(as % of merchandise exports) in Euro area in 2000 to that in 2003?
Give a very brief answer. 1.03. What is the ratio of the Imports(as % of merchandise exports) in Albania in 2000 to that in 2003?
Keep it short and to the point. 1.04. What is the ratio of the Imports(as % of merchandise exports) in Lesotho in 2000 to that in 2003?
Offer a terse response. 2.88. What is the ratio of the Imports(as % of merchandise exports) in East Asia (all income levels) in 2000 to that in 2004?
Provide a short and direct response. 0.93. What is the ratio of the Imports(as % of merchandise exports) of Euro area in 2000 to that in 2004?
Make the answer very short. 0.96. What is the ratio of the Imports(as % of merchandise exports) of Albania in 2000 to that in 2004?
Offer a terse response. 1.16. What is the ratio of the Imports(as % of merchandise exports) in Lesotho in 2000 to that in 2004?
Provide a succinct answer. 2.92. What is the ratio of the Imports(as % of merchandise exports) of East Asia (all income levels) in 2000 to that in 2008?
Make the answer very short. 0.58. What is the ratio of the Imports(as % of merchandise exports) in Euro area in 2000 to that in 2008?
Make the answer very short. 0.63. What is the ratio of the Imports(as % of merchandise exports) in Albania in 2000 to that in 2008?
Provide a short and direct response. 0.56. What is the ratio of the Imports(as % of merchandise exports) in Lesotho in 2000 to that in 2008?
Offer a terse response. 1.77. What is the ratio of the Imports(as % of merchandise exports) in East Asia (all income levels) in 2001 to that in 2002?
Make the answer very short. 1.06. What is the ratio of the Imports(as % of merchandise exports) of Euro area in 2001 to that in 2002?
Give a very brief answer. 1.04. What is the ratio of the Imports(as % of merchandise exports) in Albania in 2001 to that in 2002?
Make the answer very short. 1.09. What is the ratio of the Imports(as % of merchandise exports) of Lesotho in 2001 to that in 2002?
Ensure brevity in your answer.  0.8. What is the ratio of the Imports(as % of merchandise exports) in Euro area in 2001 to that in 2003?
Your answer should be very brief. 1. What is the ratio of the Imports(as % of merchandise exports) in Albania in 2001 to that in 2003?
Offer a terse response. 1.15. What is the ratio of the Imports(as % of merchandise exports) of Lesotho in 2001 to that in 2003?
Give a very brief answer. 0.92. What is the ratio of the Imports(as % of merchandise exports) of East Asia (all income levels) in 2001 to that in 2004?
Provide a short and direct response. 0.91. What is the ratio of the Imports(as % of merchandise exports) in Euro area in 2001 to that in 2004?
Your answer should be compact. 0.94. What is the ratio of the Imports(as % of merchandise exports) in Albania in 2001 to that in 2004?
Keep it short and to the point. 1.28. What is the ratio of the Imports(as % of merchandise exports) in Lesotho in 2001 to that in 2004?
Offer a terse response. 0.93. What is the ratio of the Imports(as % of merchandise exports) in East Asia (all income levels) in 2001 to that in 2008?
Give a very brief answer. 0.56. What is the ratio of the Imports(as % of merchandise exports) of Euro area in 2001 to that in 2008?
Your response must be concise. 0.61. What is the ratio of the Imports(as % of merchandise exports) in Albania in 2001 to that in 2008?
Offer a very short reply. 0.62. What is the ratio of the Imports(as % of merchandise exports) in Lesotho in 2001 to that in 2008?
Make the answer very short. 0.56. What is the ratio of the Imports(as % of merchandise exports) in East Asia (all income levels) in 2002 to that in 2003?
Keep it short and to the point. 0.94. What is the ratio of the Imports(as % of merchandise exports) in Euro area in 2002 to that in 2003?
Offer a terse response. 0.97. What is the ratio of the Imports(as % of merchandise exports) in Albania in 2002 to that in 2003?
Your answer should be very brief. 1.06. What is the ratio of the Imports(as % of merchandise exports) of Lesotho in 2002 to that in 2003?
Your response must be concise. 1.15. What is the ratio of the Imports(as % of merchandise exports) in East Asia (all income levels) in 2002 to that in 2004?
Provide a short and direct response. 0.86. What is the ratio of the Imports(as % of merchandise exports) of Euro area in 2002 to that in 2004?
Your answer should be compact. 0.9. What is the ratio of the Imports(as % of merchandise exports) of Albania in 2002 to that in 2004?
Make the answer very short. 1.17. What is the ratio of the Imports(as % of merchandise exports) of Lesotho in 2002 to that in 2004?
Make the answer very short. 1.17. What is the ratio of the Imports(as % of merchandise exports) of East Asia (all income levels) in 2002 to that in 2008?
Provide a succinct answer. 0.53. What is the ratio of the Imports(as % of merchandise exports) of Euro area in 2002 to that in 2008?
Provide a short and direct response. 0.59. What is the ratio of the Imports(as % of merchandise exports) of Albania in 2002 to that in 2008?
Offer a very short reply. 0.56. What is the ratio of the Imports(as % of merchandise exports) in Lesotho in 2002 to that in 2008?
Give a very brief answer. 0.71. What is the ratio of the Imports(as % of merchandise exports) of East Asia (all income levels) in 2003 to that in 2004?
Offer a very short reply. 0.91. What is the ratio of the Imports(as % of merchandise exports) in Euro area in 2003 to that in 2004?
Keep it short and to the point. 0.93. What is the ratio of the Imports(as % of merchandise exports) of Albania in 2003 to that in 2004?
Keep it short and to the point. 1.11. What is the ratio of the Imports(as % of merchandise exports) of Lesotho in 2003 to that in 2004?
Offer a very short reply. 1.01. What is the ratio of the Imports(as % of merchandise exports) of East Asia (all income levels) in 2003 to that in 2008?
Offer a very short reply. 0.56. What is the ratio of the Imports(as % of merchandise exports) in Euro area in 2003 to that in 2008?
Ensure brevity in your answer.  0.61. What is the ratio of the Imports(as % of merchandise exports) of Albania in 2003 to that in 2008?
Make the answer very short. 0.53. What is the ratio of the Imports(as % of merchandise exports) of Lesotho in 2003 to that in 2008?
Make the answer very short. 0.62. What is the ratio of the Imports(as % of merchandise exports) of East Asia (all income levels) in 2004 to that in 2008?
Give a very brief answer. 0.62. What is the ratio of the Imports(as % of merchandise exports) of Euro area in 2004 to that in 2008?
Make the answer very short. 0.65. What is the ratio of the Imports(as % of merchandise exports) in Albania in 2004 to that in 2008?
Your answer should be compact. 0.48. What is the ratio of the Imports(as % of merchandise exports) in Lesotho in 2004 to that in 2008?
Ensure brevity in your answer.  0.61. What is the difference between the highest and the second highest Imports(as % of merchandise exports) of East Asia (all income levels)?
Keep it short and to the point. 8.39. What is the difference between the highest and the second highest Imports(as % of merchandise exports) in Euro area?
Provide a short and direct response. 5.38. What is the difference between the highest and the second highest Imports(as % of merchandise exports) of Albania?
Offer a very short reply. 6.13. What is the difference between the highest and the second highest Imports(as % of merchandise exports) of Lesotho?
Provide a short and direct response. 8.1. What is the difference between the highest and the lowest Imports(as % of merchandise exports) in East Asia (all income levels)?
Your response must be concise. 10.3. What is the difference between the highest and the lowest Imports(as % of merchandise exports) of Euro area?
Offer a very short reply. 6.33. What is the difference between the highest and the lowest Imports(as % of merchandise exports) in Albania?
Your answer should be compact. 8.31. What is the difference between the highest and the lowest Imports(as % of merchandise exports) in Lesotho?
Your response must be concise. 12.68. 